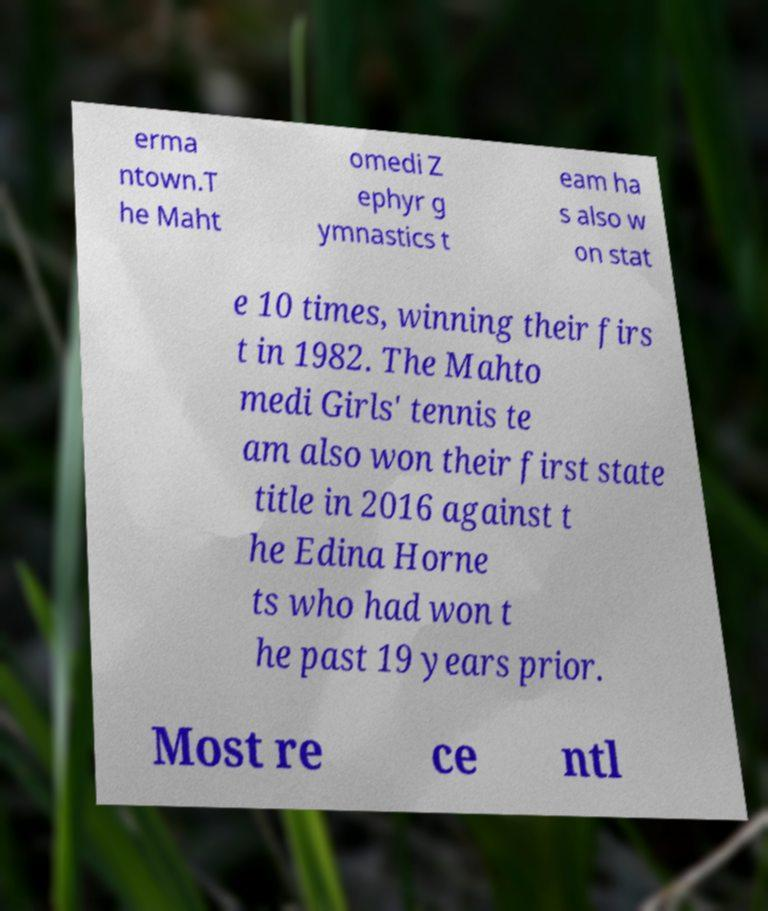Could you extract and type out the text from this image? erma ntown.T he Maht omedi Z ephyr g ymnastics t eam ha s also w on stat e 10 times, winning their firs t in 1982. The Mahto medi Girls' tennis te am also won their first state title in 2016 against t he Edina Horne ts who had won t he past 19 years prior. Most re ce ntl 